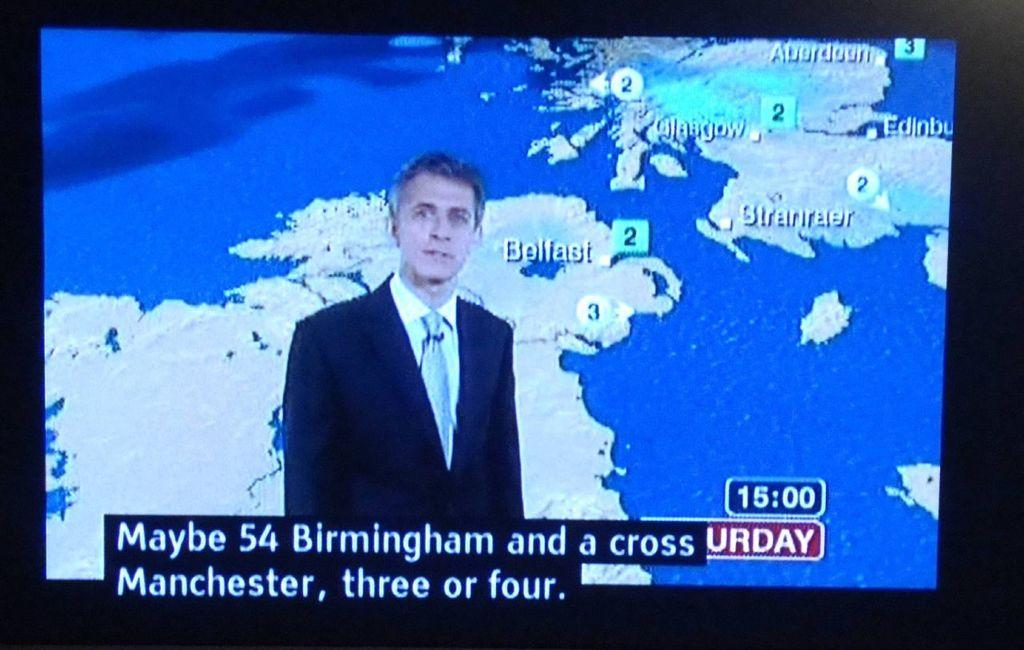<image>
Provide a brief description of the given image. A flat screen showing a news show and a post for Birmingham and Manchester game. 